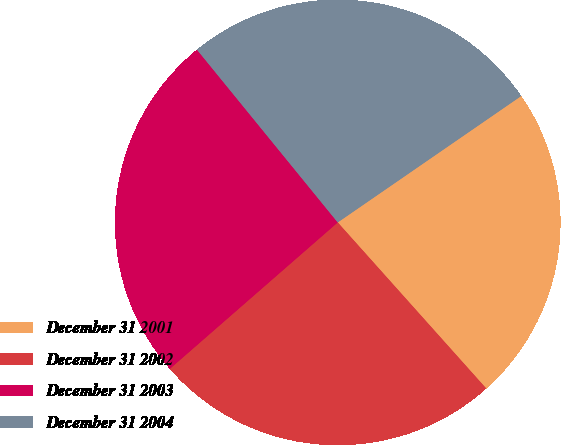<chart> <loc_0><loc_0><loc_500><loc_500><pie_chart><fcel>December 31 2001<fcel>December 31 2002<fcel>December 31 2003<fcel>December 31 2004<nl><fcel>22.99%<fcel>25.2%<fcel>25.53%<fcel>26.28%<nl></chart> 